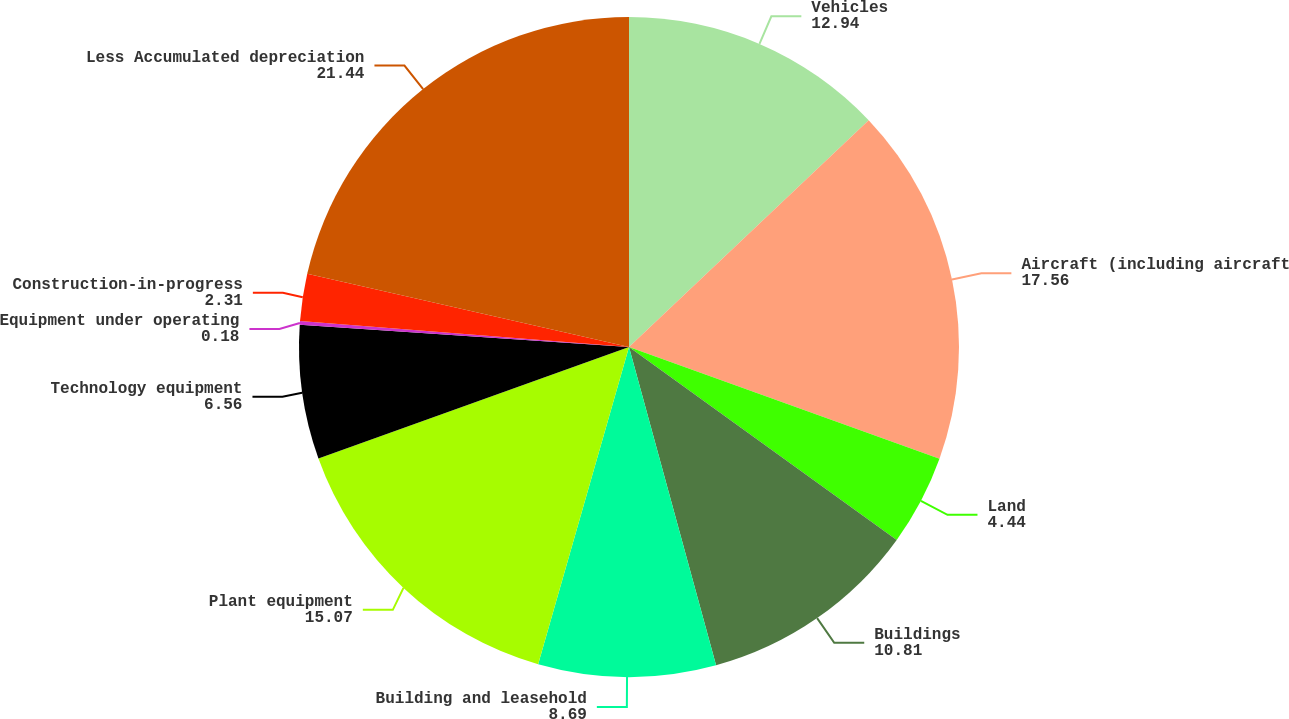Convert chart. <chart><loc_0><loc_0><loc_500><loc_500><pie_chart><fcel>Vehicles<fcel>Aircraft (including aircraft<fcel>Land<fcel>Buildings<fcel>Building and leasehold<fcel>Plant equipment<fcel>Technology equipment<fcel>Equipment under operating<fcel>Construction-in-progress<fcel>Less Accumulated depreciation<nl><fcel>12.94%<fcel>17.56%<fcel>4.44%<fcel>10.81%<fcel>8.69%<fcel>15.07%<fcel>6.56%<fcel>0.18%<fcel>2.31%<fcel>21.44%<nl></chart> 